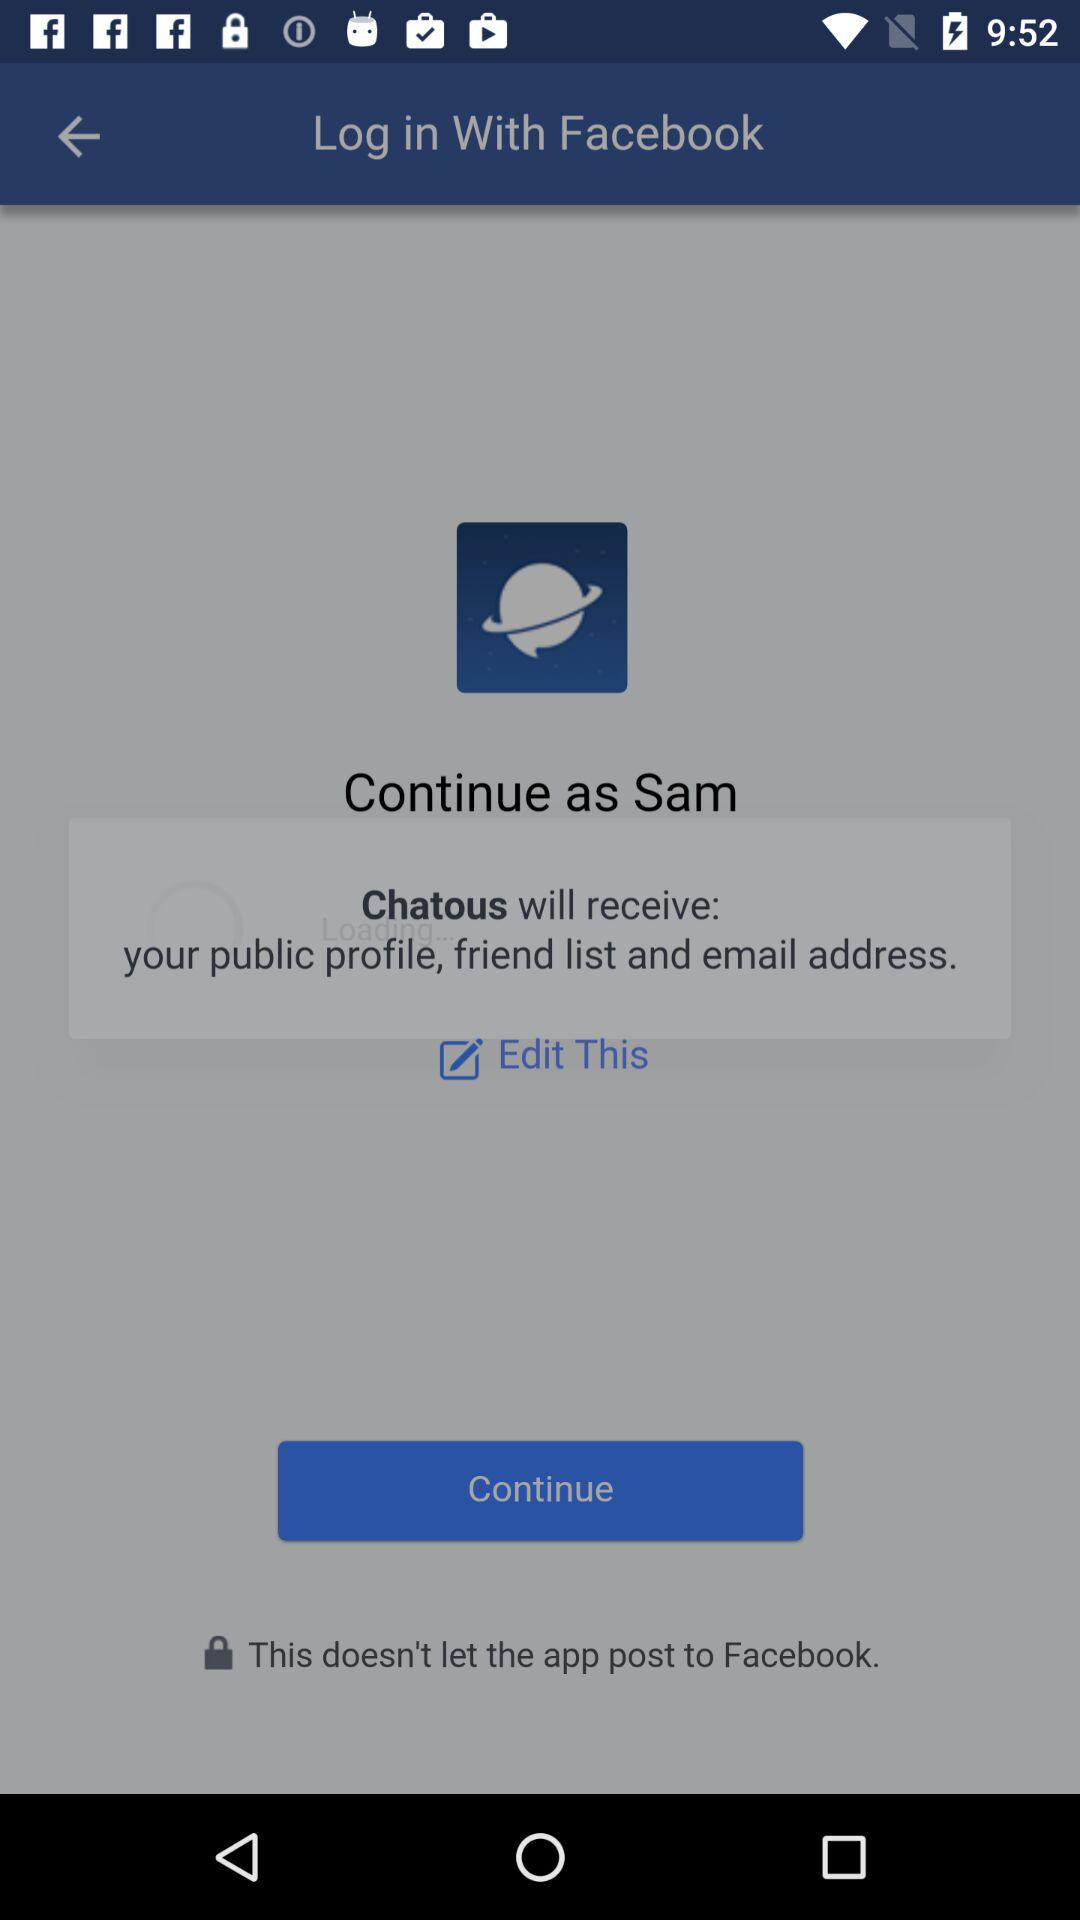What application will receive the public profile, friend list and email address? The application that will receive the public profile, friend list and email address is "Chatous". 